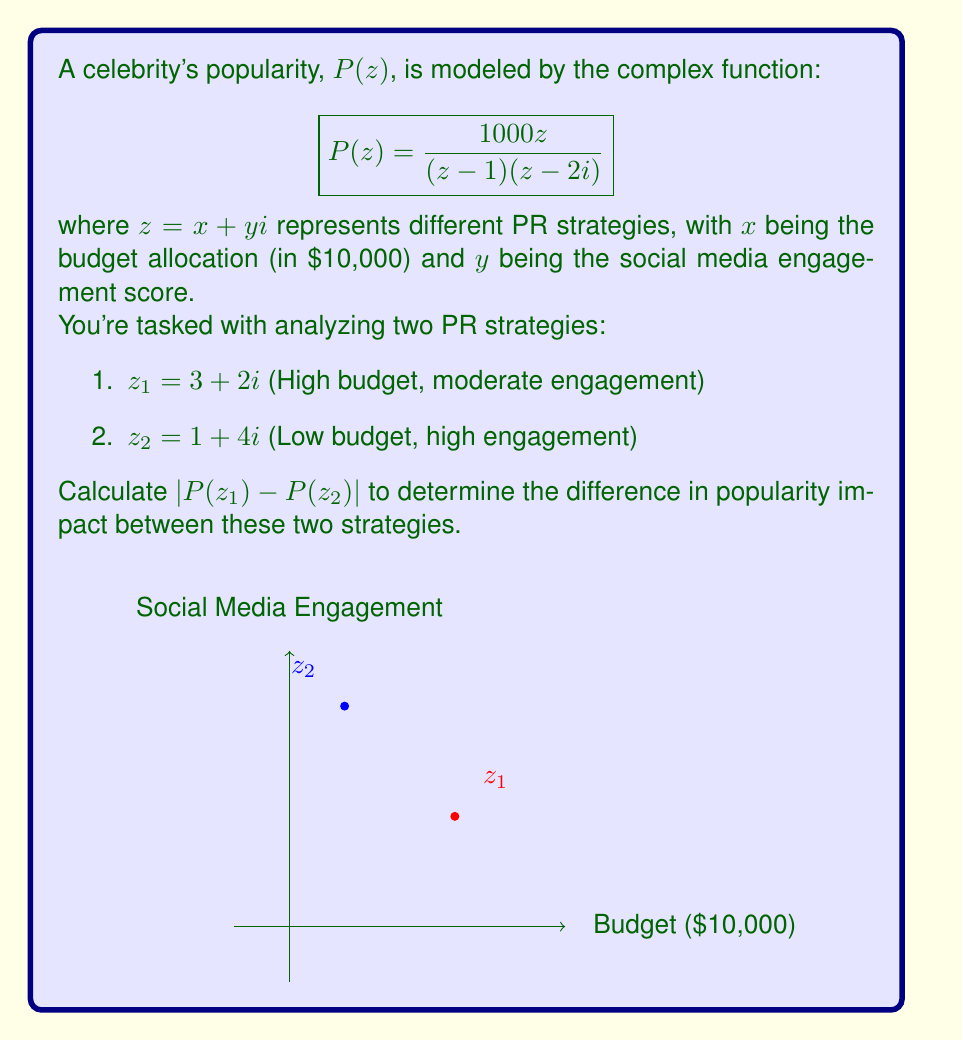Solve this math problem. Let's approach this step-by-step:

1) First, we need to calculate $P(z_1)$ and $P(z_2)$ separately.

2) For $z_1 = 3 + 2i$:
   $$P(z_1) = \frac{1000(3+2i)}{(3+2i-1)(3+2i-2i)} = \frac{1000(3+2i)}{(2+2i)(3)} = \frac{1000(3+2i)}{6+6i}$$
   
   Multiplying numerator and denominator by the complex conjugate of the denominator:
   $$P(z_1) = \frac{1000(3+2i)(6-6i)}{(6+6i)(6-6i)} = \frac{6000-6000i+4000i+4000}{72} = \frac{10000-2000i}{72}$$
   
   $$P(z_1) = \frac{500}{36} - \frac{100}{36}i \approx 138.89 - 27.78i$$

3) For $z_2 = 1 + 4i$:
   $$P(z_2) = \frac{1000(1+4i)}{(1+4i-1)(1+4i-2i)} = \frac{1000(1+4i)}{(4i)(1+2i)}$$
   
   $$= \frac{1000(1+4i)(1-2i)}{(4i)(1+2i)(1-2i)} = \frac{1000(1+4i)(1-2i)}{4i(5)} = \frac{1000(1+4i-2i-8i^2)}{20i}$$
   
   $$= \frac{1000(9+2i)}{20i} = \frac{9000+2000i}{20i} = 100 - 450i$$

4) Now, we need to calculate $P(z_1) - P(z_2)$:
   $$(138.89 - 27.78i) - (100 - 450i) = 38.89 + 422.22i$$

5) Finally, we need to find the absolute value of this difference:
   $$|P(z_1) - P(z_2)| = \sqrt{38.89^2 + 422.22^2} \approx 423.96$$

Therefore, the difference in popularity impact between these two strategies is approximately 423.96 units.
Answer: $|P(z_1) - P(z_2)| \approx 423.96$ 